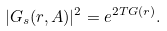<formula> <loc_0><loc_0><loc_500><loc_500>| G _ { s } ( r , A ) | ^ { 2 } = e ^ { 2 T G ( r ) } .</formula> 